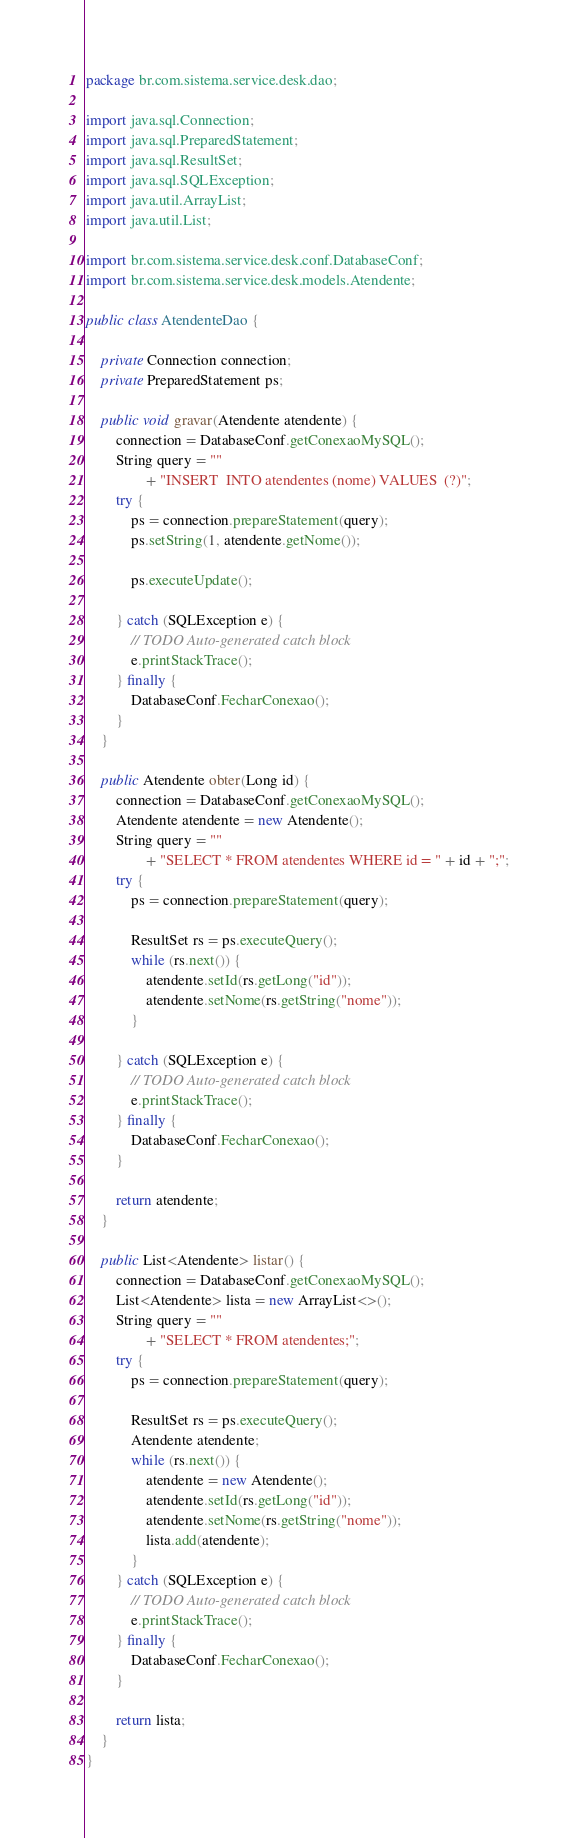Convert code to text. <code><loc_0><loc_0><loc_500><loc_500><_Java_>package br.com.sistema.service.desk.dao;

import java.sql.Connection;
import java.sql.PreparedStatement;
import java.sql.ResultSet;
import java.sql.SQLException;
import java.util.ArrayList;
import java.util.List;

import br.com.sistema.service.desk.conf.DatabaseConf;
import br.com.sistema.service.desk.models.Atendente;

public class AtendenteDao {

	private Connection connection;
	private PreparedStatement ps;
	
	public void gravar(Atendente atendente) {
		connection = DatabaseConf.getConexaoMySQL();
		String query = ""
				+ "INSERT  INTO atendentes (nome) VALUES  (?)";
		try {
			ps = connection.prepareStatement(query);
			ps.setString(1, atendente.getNome());
			
			ps.executeUpdate();
			
		} catch (SQLException e) {
			// TODO Auto-generated catch block
			e.printStackTrace();
		} finally {
			DatabaseConf.FecharConexao();
		}
	}
	
	public Atendente obter(Long id) {
		connection = DatabaseConf.getConexaoMySQL();
		Atendente atendente = new Atendente();
		String query = ""
				+ "SELECT * FROM atendentes WHERE id = " + id + ";";
		try {
			ps = connection.prepareStatement(query);
			
			ResultSet rs = ps.executeQuery();
			while (rs.next()) {
				atendente.setId(rs.getLong("id"));
				atendente.setNome(rs.getString("nome"));
			}
			
		} catch (SQLException e) {
			// TODO Auto-generated catch block
			e.printStackTrace();
		} finally {
			DatabaseConf.FecharConexao();
		}
		
		return atendente;
	}

	public List<Atendente> listar() {
		connection = DatabaseConf.getConexaoMySQL();
		List<Atendente> lista = new ArrayList<>();
		String query = ""
				+ "SELECT * FROM atendentes;";
		try {
			ps = connection.prepareStatement(query);
			
			ResultSet rs = ps.executeQuery();
			Atendente atendente;
			while (rs.next()) {
				atendente = new Atendente();
				atendente.setId(rs.getLong("id"));
				atendente.setNome(rs.getString("nome"));
				lista.add(atendente);
			}
		} catch (SQLException e) {
			// TODO Auto-generated catch block
			e.printStackTrace();
		} finally {
			DatabaseConf.FecharConexao();
		}
		
		return lista;
	}
}
</code> 